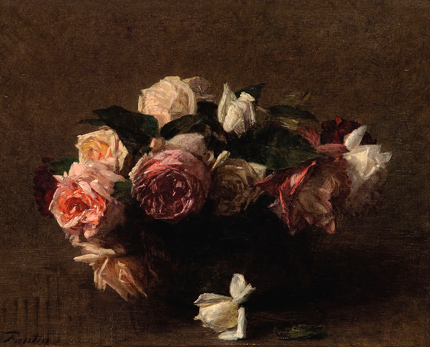How does the shadow play interact with the mood of the painting? The subtle play of shadows in the painting enhances its depth and adds a slightly melancholic or introspective mood. The shadows under the vase and around the edges of the roses create a sense of weight and temporality, which might suggest a contemplative approach to the fleeting nature of beauty. The use of shadows therefore not only adds a visual interest but also imbues the painting with emotional depth, inviting viewers to ponder deeper narratives woven into the still life. 